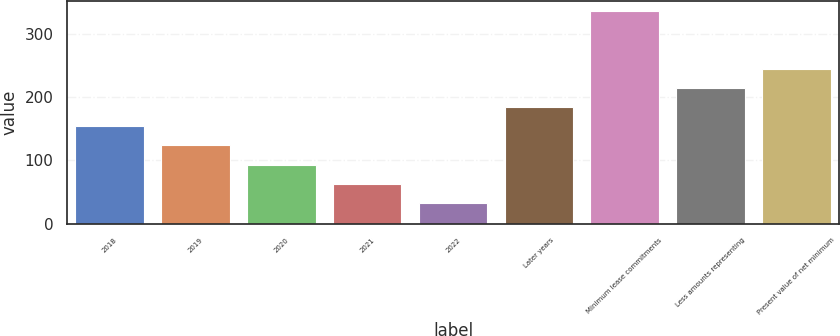Convert chart to OTSL. <chart><loc_0><loc_0><loc_500><loc_500><bar_chart><fcel>2018<fcel>2019<fcel>2020<fcel>2021<fcel>2022<fcel>Later years<fcel>Minimum lease commitments<fcel>Less amounts representing<fcel>Present value of net minimum<nl><fcel>153.8<fcel>123.6<fcel>93.4<fcel>63.2<fcel>33<fcel>184<fcel>335<fcel>214.2<fcel>244.4<nl></chart> 